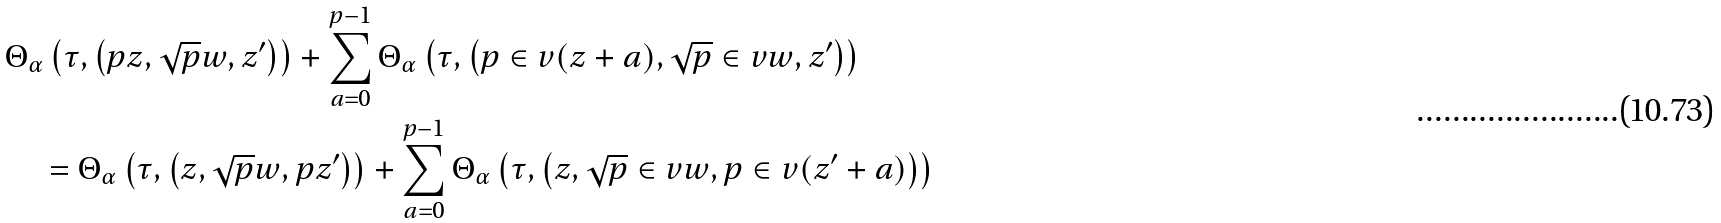Convert formula to latex. <formula><loc_0><loc_0><loc_500><loc_500>& \Theta _ { \alpha } \left ( \tau , \left ( p z , \sqrt { p } w , z ^ { \prime } \right ) \right ) + \sum _ { a = 0 } ^ { p - 1 } \Theta _ { \alpha } \left ( \tau , \left ( p \in v ( z + a ) , \sqrt { p } \in v w , z ^ { \prime } \right ) \right ) \\ & \quad = \Theta _ { \alpha } \left ( \tau , \left ( z , \sqrt { p } w , p z ^ { \prime } \right ) \right ) + \sum _ { a = 0 } ^ { p - 1 } \Theta _ { \alpha } \left ( \tau , \left ( z , \sqrt { p } \in v w , p \in v ( z ^ { \prime } + a ) \right ) \right )</formula> 